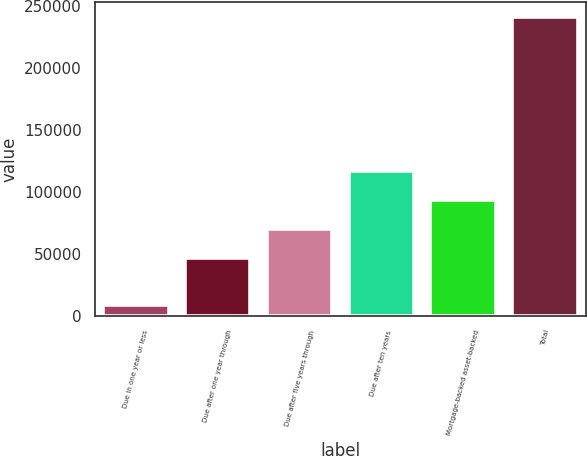<chart> <loc_0><loc_0><loc_500><loc_500><bar_chart><fcel>Due in one year or less<fcel>Due after one year through<fcel>Due after five years through<fcel>Due after ten years<fcel>Mortgage-backed asset-backed<fcel>Total<nl><fcel>9176<fcel>47230<fcel>70409.2<fcel>116768<fcel>93588.4<fcel>240968<nl></chart> 